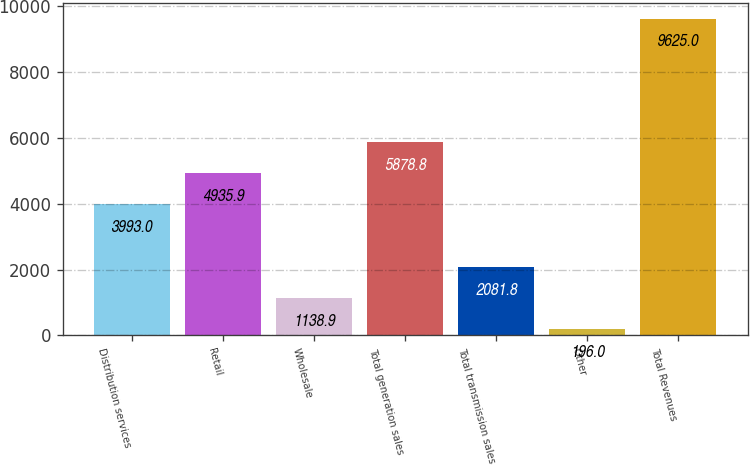Convert chart. <chart><loc_0><loc_0><loc_500><loc_500><bar_chart><fcel>Distribution services<fcel>Retail<fcel>Wholesale<fcel>Total generation sales<fcel>Total transmission sales<fcel>Other<fcel>Total Revenues<nl><fcel>3993<fcel>4935.9<fcel>1138.9<fcel>5878.8<fcel>2081.8<fcel>196<fcel>9625<nl></chart> 